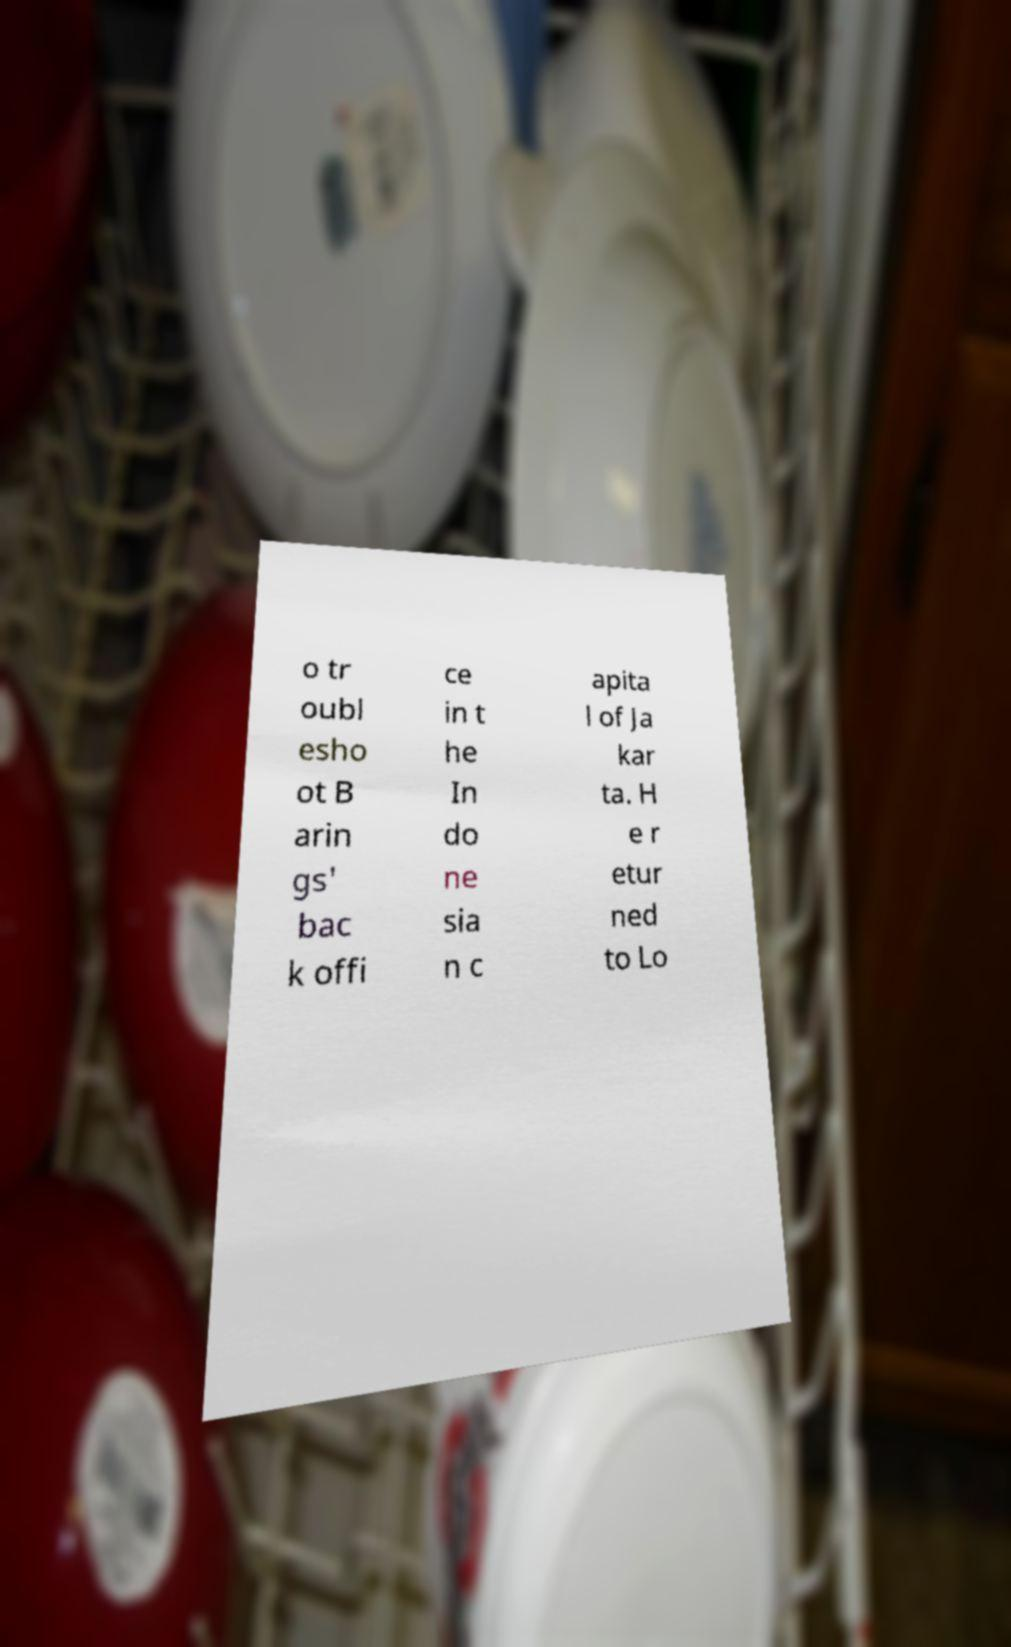Could you extract and type out the text from this image? o tr oubl esho ot B arin gs' bac k offi ce in t he In do ne sia n c apita l of Ja kar ta. H e r etur ned to Lo 